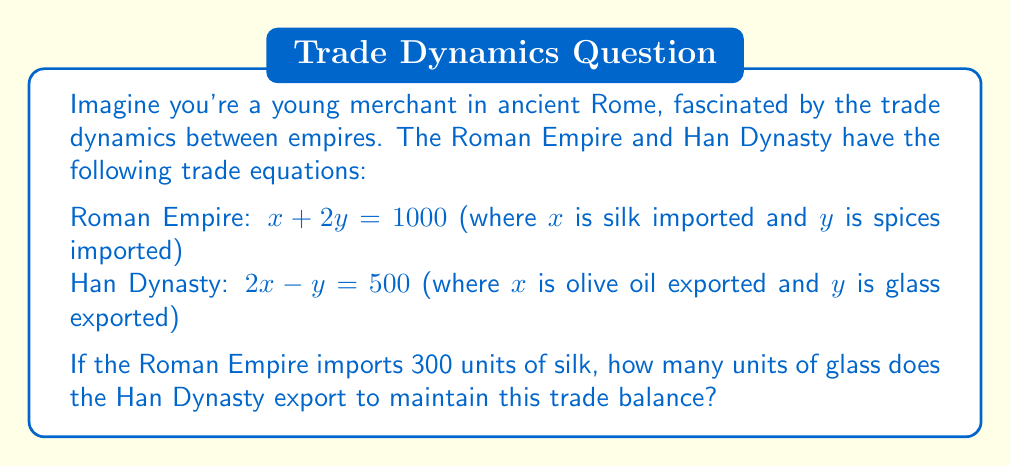Could you help me with this problem? Let's solve this step-by-step:

1) We're given that the Roman Empire imports 300 units of silk. So, $x = 300$ in the Roman Empire equation.

2) Substitute this into the Roman Empire equation:
   $300 + 2y = 1000$

3) Solve for $y$:
   $2y = 1000 - 300 = 700$
   $y = 350$

4) Now we know that the Roman Empire imports 350 units of spices.

5) For the trade to be balanced, the Han Dynasty must export the same amounts. So in the Han Dynasty equation:
   $x = 300$ (olive oil exported)
   $y = 350$ (glass exported)

6) Let's verify this in the Han Dynasty equation:
   $2(300) - 350 = 500$
   $600 - 350 = 500$
   $250 = 250$ (This checks out)

Therefore, the Han Dynasty exports 350 units of glass.
Answer: 350 units 